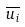<formula> <loc_0><loc_0><loc_500><loc_500>\overline { u _ { i } }</formula> 